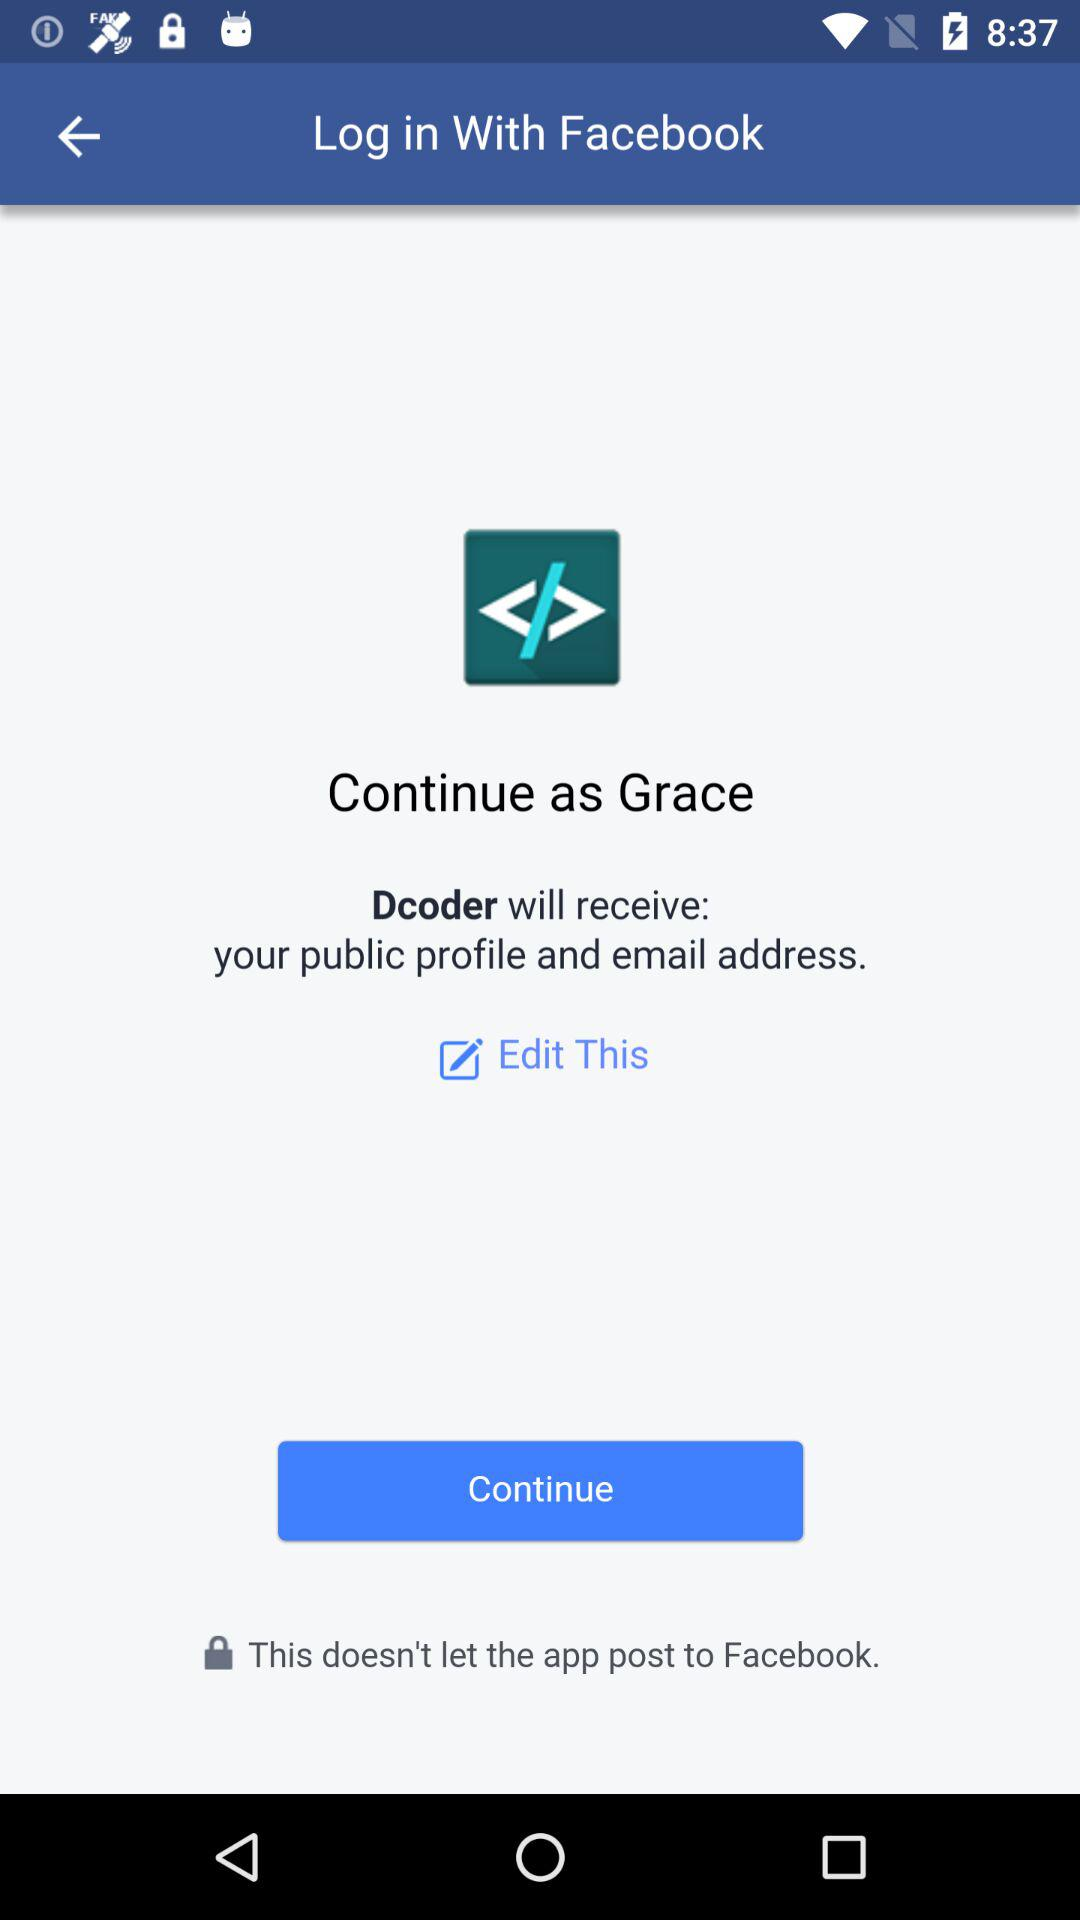What application is asking for permission? The application asking for permission is "Dcoder". 